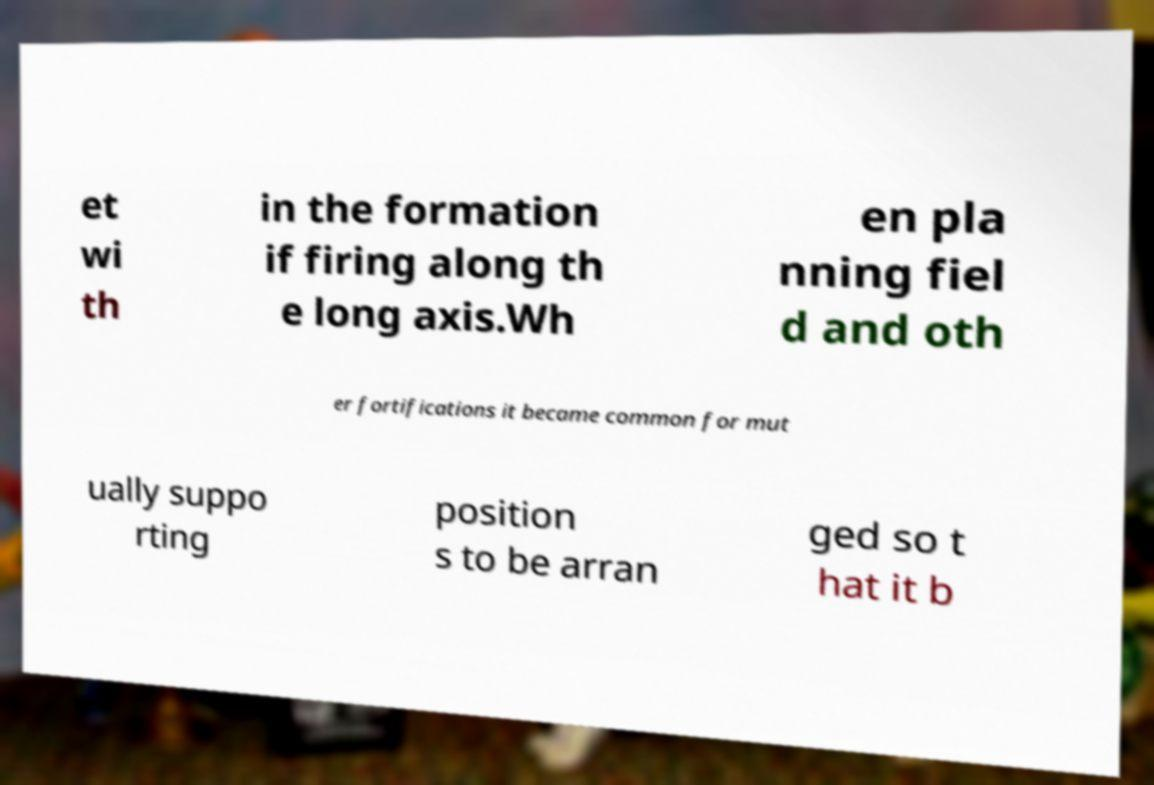Please read and relay the text visible in this image. What does it say? et wi th in the formation if firing along th e long axis.Wh en pla nning fiel d and oth er fortifications it became common for mut ually suppo rting position s to be arran ged so t hat it b 